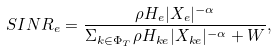Convert formula to latex. <formula><loc_0><loc_0><loc_500><loc_500>S I N R _ { e } = \frac { \rho H _ { e } | X _ { e } | ^ { - \alpha } } { \Sigma _ { k \in \Phi _ { T } } \rho H _ { k e } | X _ { k e } | ^ { - \alpha } + W } ,</formula> 